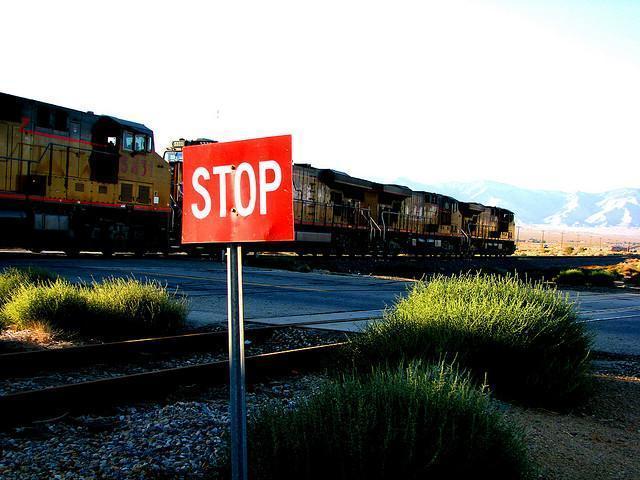How many trains are visible?
Give a very brief answer. 2. 